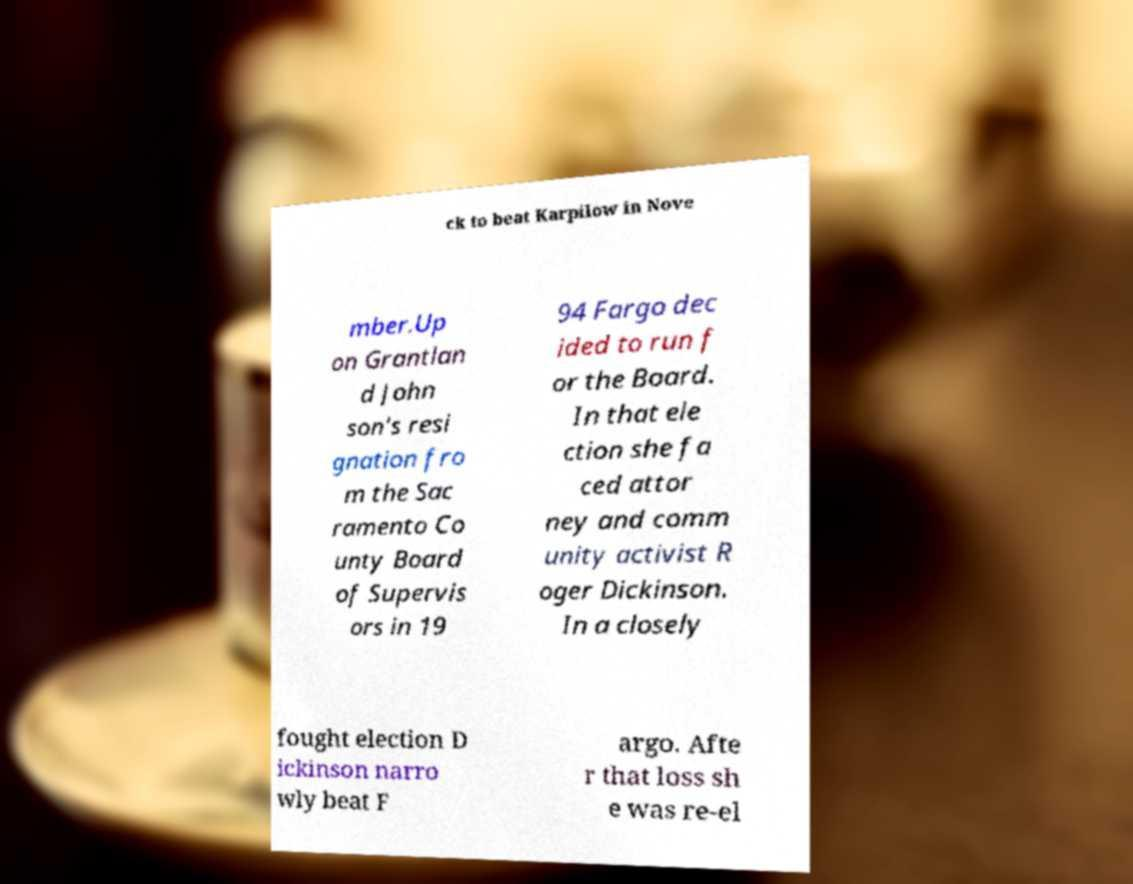I need the written content from this picture converted into text. Can you do that? ck to beat Karpilow in Nove mber.Up on Grantlan d John son's resi gnation fro m the Sac ramento Co unty Board of Supervis ors in 19 94 Fargo dec ided to run f or the Board. In that ele ction she fa ced attor ney and comm unity activist R oger Dickinson. In a closely fought election D ickinson narro wly beat F argo. Afte r that loss sh e was re-el 